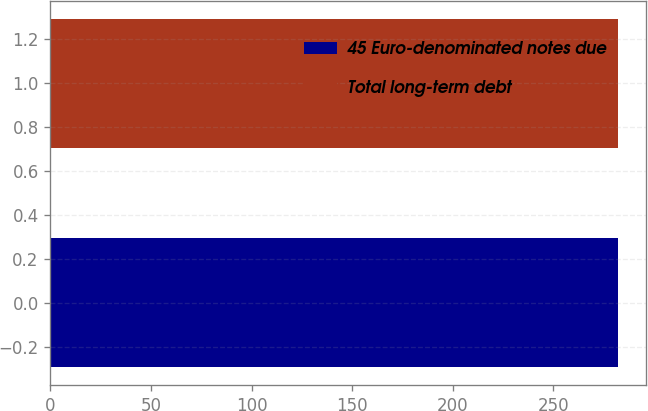<chart> <loc_0><loc_0><loc_500><loc_500><bar_chart><fcel>45 Euro-denominated notes due<fcel>Total long-term debt<nl><fcel>282.1<fcel>282.2<nl></chart> 